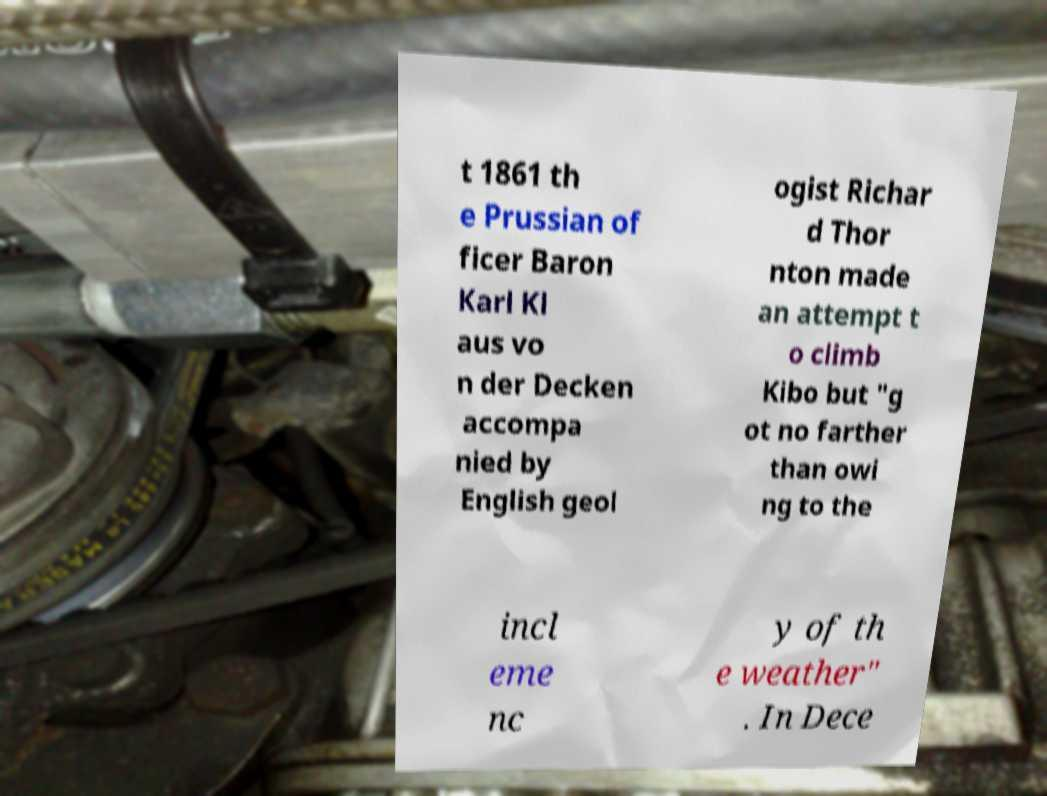What messages or text are displayed in this image? I need them in a readable, typed format. t 1861 th e Prussian of ficer Baron Karl Kl aus vo n der Decken accompa nied by English geol ogist Richar d Thor nton made an attempt t o climb Kibo but "g ot no farther than owi ng to the incl eme nc y of th e weather" . In Dece 